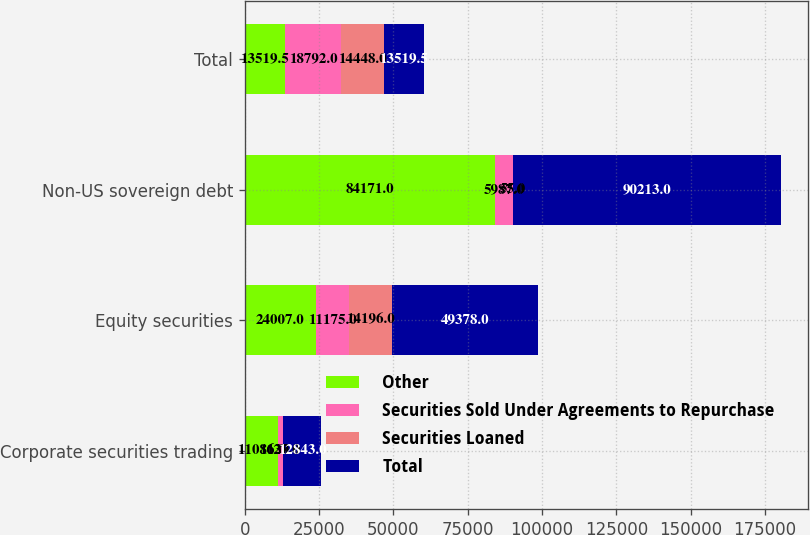Convert chart. <chart><loc_0><loc_0><loc_500><loc_500><stacked_bar_chart><ecel><fcel>Corporate securities trading<fcel>Equity securities<fcel>Non-US sovereign debt<fcel>Total<nl><fcel>Other<fcel>11086<fcel>24007<fcel>84171<fcel>13519.5<nl><fcel>Securities Sold Under Agreements to Repurchase<fcel>1630<fcel>11175<fcel>5987<fcel>18792<nl><fcel>Securities Loaned<fcel>127<fcel>14196<fcel>55<fcel>14448<nl><fcel>Total<fcel>12843<fcel>49378<fcel>90213<fcel>13519.5<nl></chart> 